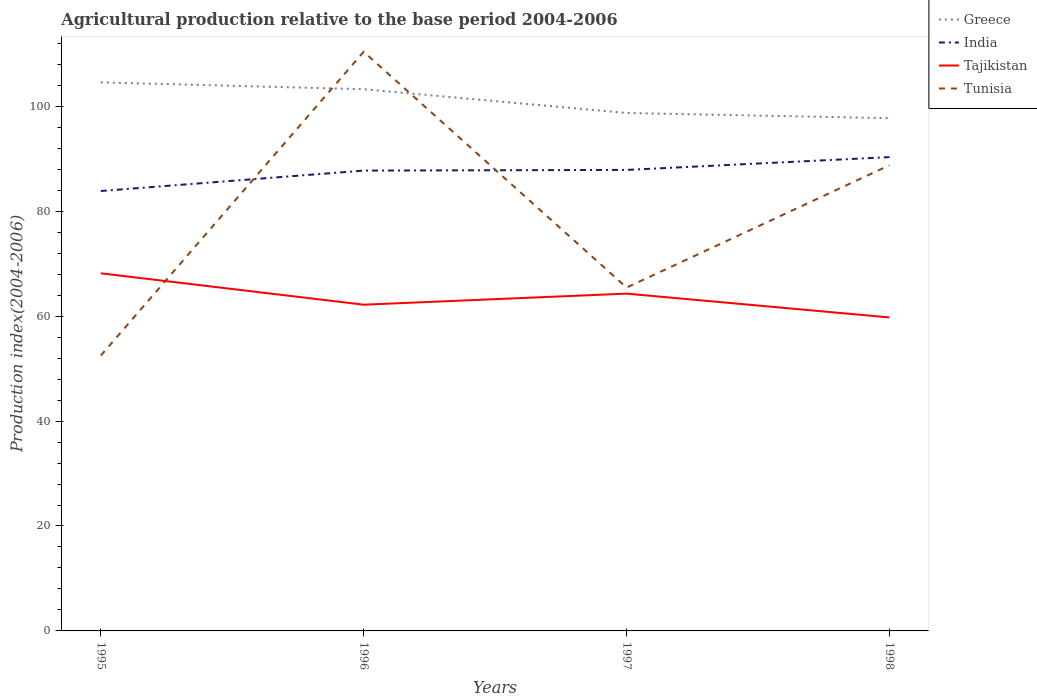How many different coloured lines are there?
Ensure brevity in your answer.  4. Is the number of lines equal to the number of legend labels?
Offer a very short reply. Yes. Across all years, what is the maximum agricultural production index in Greece?
Ensure brevity in your answer.  97.73. In which year was the agricultural production index in Tajikistan maximum?
Offer a terse response. 1998. What is the total agricultural production index in Tunisia in the graph?
Offer a very short reply. -23.31. What is the difference between the highest and the second highest agricultural production index in Tajikistan?
Your answer should be compact. 8.41. What is the difference between the highest and the lowest agricultural production index in India?
Offer a very short reply. 3. Is the agricultural production index in Tajikistan strictly greater than the agricultural production index in Greece over the years?
Your response must be concise. Yes. How many lines are there?
Ensure brevity in your answer.  4. How many years are there in the graph?
Your answer should be compact. 4. Does the graph contain any zero values?
Make the answer very short. No. Does the graph contain grids?
Make the answer very short. No. Where does the legend appear in the graph?
Your answer should be very brief. Top right. How many legend labels are there?
Your answer should be compact. 4. How are the legend labels stacked?
Offer a terse response. Vertical. What is the title of the graph?
Your response must be concise. Agricultural production relative to the base period 2004-2006. What is the label or title of the X-axis?
Provide a short and direct response. Years. What is the label or title of the Y-axis?
Give a very brief answer. Production index(2004-2006). What is the Production index(2004-2006) of Greece in 1995?
Your response must be concise. 104.56. What is the Production index(2004-2006) in India in 1995?
Provide a short and direct response. 83.85. What is the Production index(2004-2006) of Tajikistan in 1995?
Provide a succinct answer. 68.16. What is the Production index(2004-2006) in Tunisia in 1995?
Offer a very short reply. 52.49. What is the Production index(2004-2006) in Greece in 1996?
Offer a terse response. 103.25. What is the Production index(2004-2006) in India in 1996?
Your response must be concise. 87.74. What is the Production index(2004-2006) of Tajikistan in 1996?
Provide a short and direct response. 62.18. What is the Production index(2004-2006) of Tunisia in 1996?
Offer a terse response. 110.39. What is the Production index(2004-2006) of Greece in 1997?
Provide a short and direct response. 98.72. What is the Production index(2004-2006) in India in 1997?
Give a very brief answer. 87.87. What is the Production index(2004-2006) of Tajikistan in 1997?
Make the answer very short. 64.29. What is the Production index(2004-2006) of Tunisia in 1997?
Your answer should be very brief. 65.45. What is the Production index(2004-2006) of Greece in 1998?
Give a very brief answer. 97.73. What is the Production index(2004-2006) of India in 1998?
Your answer should be very brief. 90.31. What is the Production index(2004-2006) of Tajikistan in 1998?
Your answer should be very brief. 59.75. What is the Production index(2004-2006) of Tunisia in 1998?
Give a very brief answer. 88.76. Across all years, what is the maximum Production index(2004-2006) in Greece?
Your response must be concise. 104.56. Across all years, what is the maximum Production index(2004-2006) in India?
Offer a terse response. 90.31. Across all years, what is the maximum Production index(2004-2006) of Tajikistan?
Your response must be concise. 68.16. Across all years, what is the maximum Production index(2004-2006) of Tunisia?
Keep it short and to the point. 110.39. Across all years, what is the minimum Production index(2004-2006) of Greece?
Give a very brief answer. 97.73. Across all years, what is the minimum Production index(2004-2006) of India?
Provide a short and direct response. 83.85. Across all years, what is the minimum Production index(2004-2006) of Tajikistan?
Offer a very short reply. 59.75. Across all years, what is the minimum Production index(2004-2006) of Tunisia?
Ensure brevity in your answer.  52.49. What is the total Production index(2004-2006) in Greece in the graph?
Your answer should be very brief. 404.26. What is the total Production index(2004-2006) in India in the graph?
Keep it short and to the point. 349.77. What is the total Production index(2004-2006) of Tajikistan in the graph?
Ensure brevity in your answer.  254.38. What is the total Production index(2004-2006) in Tunisia in the graph?
Offer a very short reply. 317.09. What is the difference between the Production index(2004-2006) in Greece in 1995 and that in 1996?
Give a very brief answer. 1.31. What is the difference between the Production index(2004-2006) in India in 1995 and that in 1996?
Give a very brief answer. -3.89. What is the difference between the Production index(2004-2006) in Tajikistan in 1995 and that in 1996?
Provide a short and direct response. 5.98. What is the difference between the Production index(2004-2006) in Tunisia in 1995 and that in 1996?
Ensure brevity in your answer.  -57.9. What is the difference between the Production index(2004-2006) of Greece in 1995 and that in 1997?
Your answer should be very brief. 5.84. What is the difference between the Production index(2004-2006) of India in 1995 and that in 1997?
Your response must be concise. -4.02. What is the difference between the Production index(2004-2006) in Tajikistan in 1995 and that in 1997?
Make the answer very short. 3.87. What is the difference between the Production index(2004-2006) in Tunisia in 1995 and that in 1997?
Your answer should be compact. -12.96. What is the difference between the Production index(2004-2006) of Greece in 1995 and that in 1998?
Keep it short and to the point. 6.83. What is the difference between the Production index(2004-2006) in India in 1995 and that in 1998?
Give a very brief answer. -6.46. What is the difference between the Production index(2004-2006) in Tajikistan in 1995 and that in 1998?
Provide a succinct answer. 8.41. What is the difference between the Production index(2004-2006) in Tunisia in 1995 and that in 1998?
Keep it short and to the point. -36.27. What is the difference between the Production index(2004-2006) in Greece in 1996 and that in 1997?
Give a very brief answer. 4.53. What is the difference between the Production index(2004-2006) in India in 1996 and that in 1997?
Your response must be concise. -0.13. What is the difference between the Production index(2004-2006) in Tajikistan in 1996 and that in 1997?
Offer a very short reply. -2.11. What is the difference between the Production index(2004-2006) of Tunisia in 1996 and that in 1997?
Your answer should be very brief. 44.94. What is the difference between the Production index(2004-2006) of Greece in 1996 and that in 1998?
Your answer should be very brief. 5.52. What is the difference between the Production index(2004-2006) of India in 1996 and that in 1998?
Make the answer very short. -2.57. What is the difference between the Production index(2004-2006) of Tajikistan in 1996 and that in 1998?
Ensure brevity in your answer.  2.43. What is the difference between the Production index(2004-2006) in Tunisia in 1996 and that in 1998?
Your answer should be very brief. 21.63. What is the difference between the Production index(2004-2006) of India in 1997 and that in 1998?
Provide a short and direct response. -2.44. What is the difference between the Production index(2004-2006) of Tajikistan in 1997 and that in 1998?
Provide a succinct answer. 4.54. What is the difference between the Production index(2004-2006) in Tunisia in 1997 and that in 1998?
Your answer should be compact. -23.31. What is the difference between the Production index(2004-2006) in Greece in 1995 and the Production index(2004-2006) in India in 1996?
Your response must be concise. 16.82. What is the difference between the Production index(2004-2006) in Greece in 1995 and the Production index(2004-2006) in Tajikistan in 1996?
Offer a terse response. 42.38. What is the difference between the Production index(2004-2006) in Greece in 1995 and the Production index(2004-2006) in Tunisia in 1996?
Your answer should be very brief. -5.83. What is the difference between the Production index(2004-2006) in India in 1995 and the Production index(2004-2006) in Tajikistan in 1996?
Give a very brief answer. 21.67. What is the difference between the Production index(2004-2006) in India in 1995 and the Production index(2004-2006) in Tunisia in 1996?
Provide a succinct answer. -26.54. What is the difference between the Production index(2004-2006) of Tajikistan in 1995 and the Production index(2004-2006) of Tunisia in 1996?
Ensure brevity in your answer.  -42.23. What is the difference between the Production index(2004-2006) in Greece in 1995 and the Production index(2004-2006) in India in 1997?
Your response must be concise. 16.69. What is the difference between the Production index(2004-2006) in Greece in 1995 and the Production index(2004-2006) in Tajikistan in 1997?
Provide a short and direct response. 40.27. What is the difference between the Production index(2004-2006) in Greece in 1995 and the Production index(2004-2006) in Tunisia in 1997?
Your response must be concise. 39.11. What is the difference between the Production index(2004-2006) in India in 1995 and the Production index(2004-2006) in Tajikistan in 1997?
Your response must be concise. 19.56. What is the difference between the Production index(2004-2006) of Tajikistan in 1995 and the Production index(2004-2006) of Tunisia in 1997?
Offer a terse response. 2.71. What is the difference between the Production index(2004-2006) in Greece in 1995 and the Production index(2004-2006) in India in 1998?
Make the answer very short. 14.25. What is the difference between the Production index(2004-2006) of Greece in 1995 and the Production index(2004-2006) of Tajikistan in 1998?
Your answer should be compact. 44.81. What is the difference between the Production index(2004-2006) in Greece in 1995 and the Production index(2004-2006) in Tunisia in 1998?
Provide a short and direct response. 15.8. What is the difference between the Production index(2004-2006) in India in 1995 and the Production index(2004-2006) in Tajikistan in 1998?
Ensure brevity in your answer.  24.1. What is the difference between the Production index(2004-2006) in India in 1995 and the Production index(2004-2006) in Tunisia in 1998?
Offer a very short reply. -4.91. What is the difference between the Production index(2004-2006) of Tajikistan in 1995 and the Production index(2004-2006) of Tunisia in 1998?
Your response must be concise. -20.6. What is the difference between the Production index(2004-2006) of Greece in 1996 and the Production index(2004-2006) of India in 1997?
Make the answer very short. 15.38. What is the difference between the Production index(2004-2006) of Greece in 1996 and the Production index(2004-2006) of Tajikistan in 1997?
Make the answer very short. 38.96. What is the difference between the Production index(2004-2006) in Greece in 1996 and the Production index(2004-2006) in Tunisia in 1997?
Your response must be concise. 37.8. What is the difference between the Production index(2004-2006) in India in 1996 and the Production index(2004-2006) in Tajikistan in 1997?
Keep it short and to the point. 23.45. What is the difference between the Production index(2004-2006) of India in 1996 and the Production index(2004-2006) of Tunisia in 1997?
Offer a very short reply. 22.29. What is the difference between the Production index(2004-2006) of Tajikistan in 1996 and the Production index(2004-2006) of Tunisia in 1997?
Make the answer very short. -3.27. What is the difference between the Production index(2004-2006) in Greece in 1996 and the Production index(2004-2006) in India in 1998?
Your answer should be compact. 12.94. What is the difference between the Production index(2004-2006) in Greece in 1996 and the Production index(2004-2006) in Tajikistan in 1998?
Provide a short and direct response. 43.5. What is the difference between the Production index(2004-2006) in Greece in 1996 and the Production index(2004-2006) in Tunisia in 1998?
Your answer should be very brief. 14.49. What is the difference between the Production index(2004-2006) of India in 1996 and the Production index(2004-2006) of Tajikistan in 1998?
Provide a succinct answer. 27.99. What is the difference between the Production index(2004-2006) of India in 1996 and the Production index(2004-2006) of Tunisia in 1998?
Your response must be concise. -1.02. What is the difference between the Production index(2004-2006) in Tajikistan in 1996 and the Production index(2004-2006) in Tunisia in 1998?
Offer a very short reply. -26.58. What is the difference between the Production index(2004-2006) in Greece in 1997 and the Production index(2004-2006) in India in 1998?
Make the answer very short. 8.41. What is the difference between the Production index(2004-2006) of Greece in 1997 and the Production index(2004-2006) of Tajikistan in 1998?
Your answer should be very brief. 38.97. What is the difference between the Production index(2004-2006) of Greece in 1997 and the Production index(2004-2006) of Tunisia in 1998?
Offer a very short reply. 9.96. What is the difference between the Production index(2004-2006) in India in 1997 and the Production index(2004-2006) in Tajikistan in 1998?
Your response must be concise. 28.12. What is the difference between the Production index(2004-2006) in India in 1997 and the Production index(2004-2006) in Tunisia in 1998?
Ensure brevity in your answer.  -0.89. What is the difference between the Production index(2004-2006) in Tajikistan in 1997 and the Production index(2004-2006) in Tunisia in 1998?
Give a very brief answer. -24.47. What is the average Production index(2004-2006) of Greece per year?
Your answer should be very brief. 101.06. What is the average Production index(2004-2006) in India per year?
Your response must be concise. 87.44. What is the average Production index(2004-2006) of Tajikistan per year?
Offer a terse response. 63.59. What is the average Production index(2004-2006) in Tunisia per year?
Give a very brief answer. 79.27. In the year 1995, what is the difference between the Production index(2004-2006) of Greece and Production index(2004-2006) of India?
Provide a succinct answer. 20.71. In the year 1995, what is the difference between the Production index(2004-2006) of Greece and Production index(2004-2006) of Tajikistan?
Offer a terse response. 36.4. In the year 1995, what is the difference between the Production index(2004-2006) of Greece and Production index(2004-2006) of Tunisia?
Make the answer very short. 52.07. In the year 1995, what is the difference between the Production index(2004-2006) in India and Production index(2004-2006) in Tajikistan?
Your response must be concise. 15.69. In the year 1995, what is the difference between the Production index(2004-2006) of India and Production index(2004-2006) of Tunisia?
Make the answer very short. 31.36. In the year 1995, what is the difference between the Production index(2004-2006) of Tajikistan and Production index(2004-2006) of Tunisia?
Keep it short and to the point. 15.67. In the year 1996, what is the difference between the Production index(2004-2006) in Greece and Production index(2004-2006) in India?
Provide a short and direct response. 15.51. In the year 1996, what is the difference between the Production index(2004-2006) in Greece and Production index(2004-2006) in Tajikistan?
Offer a very short reply. 41.07. In the year 1996, what is the difference between the Production index(2004-2006) of Greece and Production index(2004-2006) of Tunisia?
Provide a short and direct response. -7.14. In the year 1996, what is the difference between the Production index(2004-2006) in India and Production index(2004-2006) in Tajikistan?
Your answer should be very brief. 25.56. In the year 1996, what is the difference between the Production index(2004-2006) of India and Production index(2004-2006) of Tunisia?
Your answer should be very brief. -22.65. In the year 1996, what is the difference between the Production index(2004-2006) of Tajikistan and Production index(2004-2006) of Tunisia?
Make the answer very short. -48.21. In the year 1997, what is the difference between the Production index(2004-2006) of Greece and Production index(2004-2006) of India?
Your answer should be compact. 10.85. In the year 1997, what is the difference between the Production index(2004-2006) of Greece and Production index(2004-2006) of Tajikistan?
Your answer should be very brief. 34.43. In the year 1997, what is the difference between the Production index(2004-2006) of Greece and Production index(2004-2006) of Tunisia?
Offer a terse response. 33.27. In the year 1997, what is the difference between the Production index(2004-2006) in India and Production index(2004-2006) in Tajikistan?
Your response must be concise. 23.58. In the year 1997, what is the difference between the Production index(2004-2006) in India and Production index(2004-2006) in Tunisia?
Make the answer very short. 22.42. In the year 1997, what is the difference between the Production index(2004-2006) of Tajikistan and Production index(2004-2006) of Tunisia?
Offer a very short reply. -1.16. In the year 1998, what is the difference between the Production index(2004-2006) in Greece and Production index(2004-2006) in India?
Give a very brief answer. 7.42. In the year 1998, what is the difference between the Production index(2004-2006) of Greece and Production index(2004-2006) of Tajikistan?
Your response must be concise. 37.98. In the year 1998, what is the difference between the Production index(2004-2006) of Greece and Production index(2004-2006) of Tunisia?
Ensure brevity in your answer.  8.97. In the year 1998, what is the difference between the Production index(2004-2006) in India and Production index(2004-2006) in Tajikistan?
Offer a terse response. 30.56. In the year 1998, what is the difference between the Production index(2004-2006) of India and Production index(2004-2006) of Tunisia?
Offer a terse response. 1.55. In the year 1998, what is the difference between the Production index(2004-2006) of Tajikistan and Production index(2004-2006) of Tunisia?
Offer a very short reply. -29.01. What is the ratio of the Production index(2004-2006) of Greece in 1995 to that in 1996?
Your answer should be compact. 1.01. What is the ratio of the Production index(2004-2006) of India in 1995 to that in 1996?
Give a very brief answer. 0.96. What is the ratio of the Production index(2004-2006) of Tajikistan in 1995 to that in 1996?
Give a very brief answer. 1.1. What is the ratio of the Production index(2004-2006) in Tunisia in 1995 to that in 1996?
Your response must be concise. 0.48. What is the ratio of the Production index(2004-2006) of Greece in 1995 to that in 1997?
Make the answer very short. 1.06. What is the ratio of the Production index(2004-2006) in India in 1995 to that in 1997?
Give a very brief answer. 0.95. What is the ratio of the Production index(2004-2006) of Tajikistan in 1995 to that in 1997?
Provide a short and direct response. 1.06. What is the ratio of the Production index(2004-2006) in Tunisia in 1995 to that in 1997?
Ensure brevity in your answer.  0.8. What is the ratio of the Production index(2004-2006) in Greece in 1995 to that in 1998?
Make the answer very short. 1.07. What is the ratio of the Production index(2004-2006) of India in 1995 to that in 1998?
Make the answer very short. 0.93. What is the ratio of the Production index(2004-2006) of Tajikistan in 1995 to that in 1998?
Provide a short and direct response. 1.14. What is the ratio of the Production index(2004-2006) of Tunisia in 1995 to that in 1998?
Provide a short and direct response. 0.59. What is the ratio of the Production index(2004-2006) in Greece in 1996 to that in 1997?
Your answer should be compact. 1.05. What is the ratio of the Production index(2004-2006) in Tajikistan in 1996 to that in 1997?
Give a very brief answer. 0.97. What is the ratio of the Production index(2004-2006) of Tunisia in 1996 to that in 1997?
Provide a short and direct response. 1.69. What is the ratio of the Production index(2004-2006) of Greece in 1996 to that in 1998?
Make the answer very short. 1.06. What is the ratio of the Production index(2004-2006) in India in 1996 to that in 1998?
Your response must be concise. 0.97. What is the ratio of the Production index(2004-2006) of Tajikistan in 1996 to that in 1998?
Offer a very short reply. 1.04. What is the ratio of the Production index(2004-2006) of Tunisia in 1996 to that in 1998?
Your answer should be very brief. 1.24. What is the ratio of the Production index(2004-2006) of Greece in 1997 to that in 1998?
Your response must be concise. 1.01. What is the ratio of the Production index(2004-2006) of Tajikistan in 1997 to that in 1998?
Your answer should be very brief. 1.08. What is the ratio of the Production index(2004-2006) of Tunisia in 1997 to that in 1998?
Provide a short and direct response. 0.74. What is the difference between the highest and the second highest Production index(2004-2006) in Greece?
Make the answer very short. 1.31. What is the difference between the highest and the second highest Production index(2004-2006) in India?
Provide a short and direct response. 2.44. What is the difference between the highest and the second highest Production index(2004-2006) of Tajikistan?
Give a very brief answer. 3.87. What is the difference between the highest and the second highest Production index(2004-2006) of Tunisia?
Ensure brevity in your answer.  21.63. What is the difference between the highest and the lowest Production index(2004-2006) of Greece?
Offer a terse response. 6.83. What is the difference between the highest and the lowest Production index(2004-2006) in India?
Keep it short and to the point. 6.46. What is the difference between the highest and the lowest Production index(2004-2006) in Tajikistan?
Provide a short and direct response. 8.41. What is the difference between the highest and the lowest Production index(2004-2006) of Tunisia?
Make the answer very short. 57.9. 